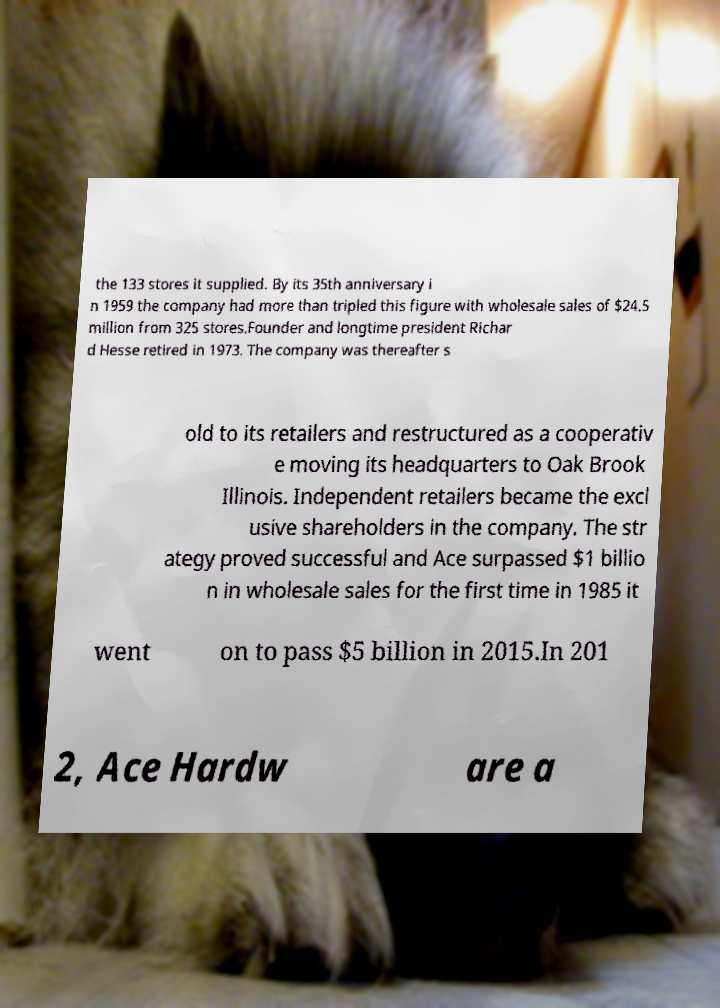There's text embedded in this image that I need extracted. Can you transcribe it verbatim? the 133 stores it supplied. By its 35th anniversary i n 1959 the company had more than tripled this figure with wholesale sales of $24.5 million from 325 stores.Founder and longtime president Richar d Hesse retired in 1973. The company was thereafter s old to its retailers and restructured as a cooperativ e moving its headquarters to Oak Brook Illinois. Independent retailers became the excl usive shareholders in the company. The str ategy proved successful and Ace surpassed $1 billio n in wholesale sales for the first time in 1985 it went on to pass $5 billion in 2015.In 201 2, Ace Hardw are a 